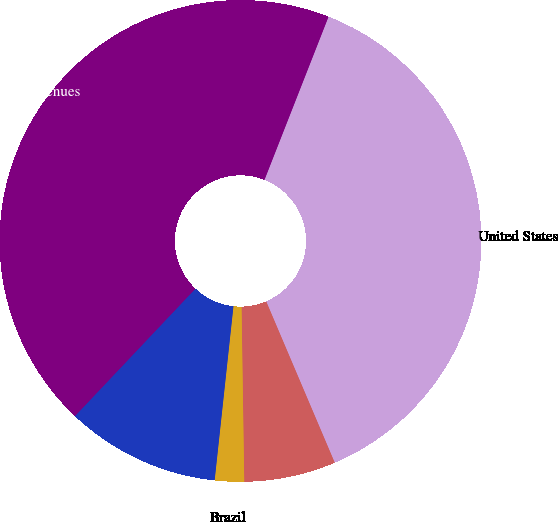Convert chart. <chart><loc_0><loc_0><loc_500><loc_500><pie_chart><fcel>United States<fcel>Mexico<fcel>Brazil<fcel>Total International<fcel>Total operating revenues<nl><fcel>37.65%<fcel>6.15%<fcel>1.96%<fcel>10.34%<fcel>43.9%<nl></chart> 